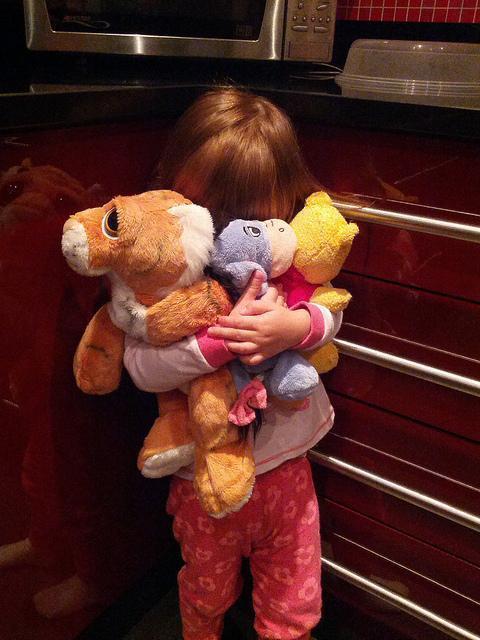What type of animal is the middle toy the child is holding?
From the following set of four choices, select the accurate answer to respond to the question.
Options: Pig, donkey, tiger, bear. Donkey. 